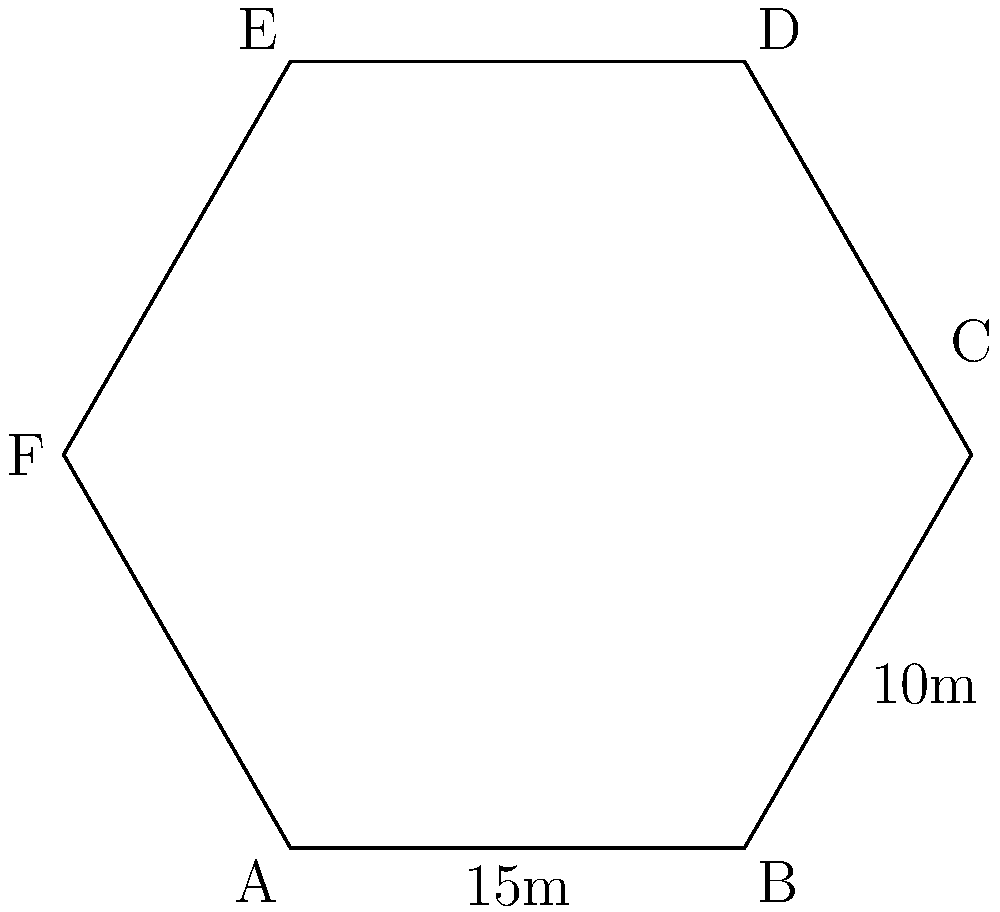A hexagonal outdoor recreation area is being designed for young offenders as part of their mental health rehabilitation program. The area is shaped like a regular hexagon, with two known side lengths: AB = 15m and BC = 10m. Calculate the perimeter of the entire recreation area. To find the perimeter of the hexagonal recreation area, we need to follow these steps:

1) In a regular hexagon, all sides are equal in length.

2) We are given two side lengths:
   AB = 15m
   BC = 10m

3) Since the hexagon is regular, we know that all sides must be equal. Therefore, we should use the longer length (15m) for our calculation.

4) A hexagon has 6 sides. To calculate the perimeter, we multiply the length of one side by 6:

   Perimeter = 6 * side length
              = 6 * 15m
              = 90m

Therefore, the perimeter of the hexagonal recreation area is 90 meters.
Answer: 90m 